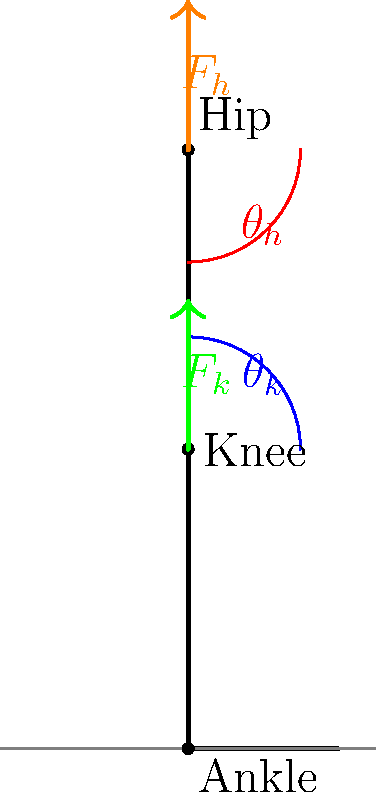Consider the skeletal diagram of a person performing a squat exercise. Given that the knee angle ($\theta_k$) is 60° and the hip angle ($\theta_h$) is 45°, calculate the ratio of the force at the knee joint ($F_k$) to the force at the hip joint ($F_h$) assuming static equilibrium and neglecting the mass of the leg segments. Use the principle of moments and assume the center of mass of the body is directly above the hip joint. To solve this problem, we'll follow these steps:

1) In static equilibrium, the sum of moments about any point should be zero. Let's choose the hip joint as our reference point.

2) The force at the knee ($F_k$) creates a moment about the hip. The moment arm is the perpendicular distance from the hip to the line of action of $F_k$.

3) The moment arm can be calculated as:
   $d = L \sin(\theta_h)$
   where $L$ is the length of the thigh (distance from hip to knee).

4) The moment equation about the hip is:
   $F_k \cdot L \sin(\theta_h) - F_h \cdot 0 = 0$
   (Note: $F_h$ has no moment arm about the hip)

5) Simplify:
   $F_k \cdot L \sin(\theta_h) = 0$

6) The equation doesn't give us absolute values of $F_k$ and $F_h$, but we can find their ratio:
   $\frac{F_k}{F_h} = \frac{1}{\sin(\theta_h)}$

7) Substitute the given angle:
   $\frac{F_k}{F_h} = \frac{1}{\sin(45°)} = \frac{1}{\frac{\sqrt{2}}{2}} = \sqrt{2} \approx 1.414$

Therefore, the ratio of the force at the knee to the force at the hip is $\sqrt{2}$ : 1.
Answer: $\frac{F_k}{F_h} = \sqrt{2} : 1$ 